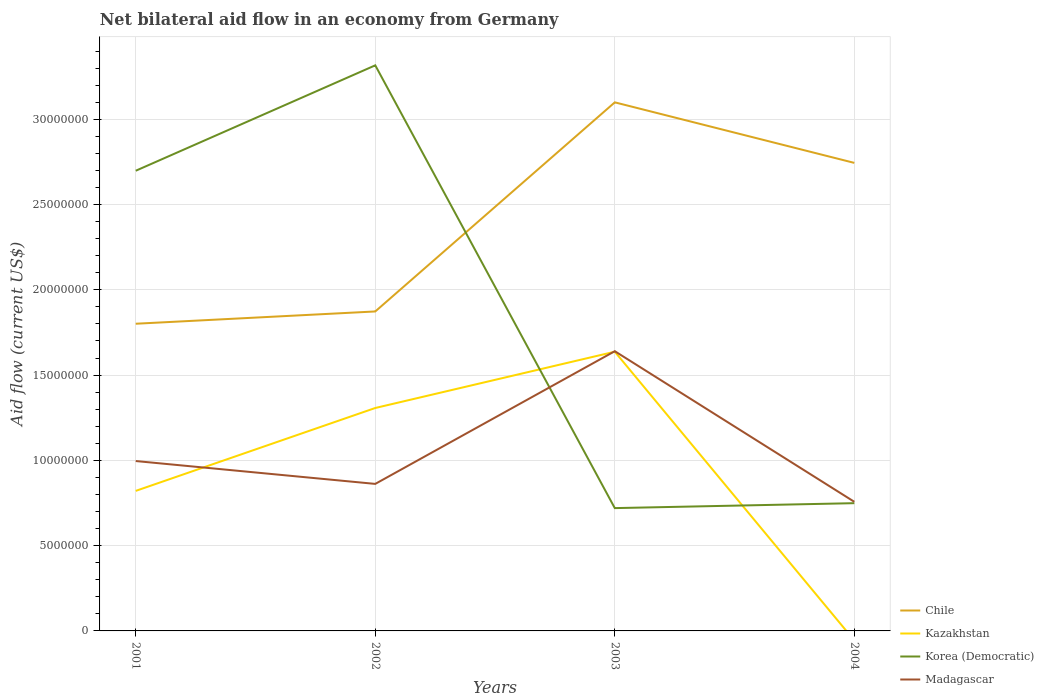How many different coloured lines are there?
Provide a succinct answer. 4. Across all years, what is the maximum net bilateral aid flow in Korea (Democratic)?
Keep it short and to the point. 7.20e+06. What is the total net bilateral aid flow in Madagascar in the graph?
Your answer should be very brief. 2.39e+06. What is the difference between the highest and the second highest net bilateral aid flow in Korea (Democratic)?
Your answer should be compact. 2.60e+07. What is the difference between the highest and the lowest net bilateral aid flow in Kazakhstan?
Provide a succinct answer. 2. Is the net bilateral aid flow in Madagascar strictly greater than the net bilateral aid flow in Kazakhstan over the years?
Ensure brevity in your answer.  No. How many years are there in the graph?
Your answer should be very brief. 4. How many legend labels are there?
Ensure brevity in your answer.  4. What is the title of the graph?
Your answer should be very brief. Net bilateral aid flow in an economy from Germany. What is the label or title of the X-axis?
Offer a terse response. Years. What is the Aid flow (current US$) of Chile in 2001?
Make the answer very short. 1.80e+07. What is the Aid flow (current US$) in Kazakhstan in 2001?
Your response must be concise. 8.21e+06. What is the Aid flow (current US$) in Korea (Democratic) in 2001?
Provide a short and direct response. 2.70e+07. What is the Aid flow (current US$) in Madagascar in 2001?
Ensure brevity in your answer.  9.96e+06. What is the Aid flow (current US$) in Chile in 2002?
Your answer should be very brief. 1.87e+07. What is the Aid flow (current US$) of Kazakhstan in 2002?
Your answer should be very brief. 1.31e+07. What is the Aid flow (current US$) in Korea (Democratic) in 2002?
Your response must be concise. 3.32e+07. What is the Aid flow (current US$) in Madagascar in 2002?
Your answer should be compact. 8.62e+06. What is the Aid flow (current US$) of Chile in 2003?
Provide a short and direct response. 3.10e+07. What is the Aid flow (current US$) in Kazakhstan in 2003?
Offer a very short reply. 1.64e+07. What is the Aid flow (current US$) of Korea (Democratic) in 2003?
Give a very brief answer. 7.20e+06. What is the Aid flow (current US$) of Madagascar in 2003?
Your answer should be very brief. 1.64e+07. What is the Aid flow (current US$) of Chile in 2004?
Give a very brief answer. 2.74e+07. What is the Aid flow (current US$) in Kazakhstan in 2004?
Offer a terse response. 0. What is the Aid flow (current US$) in Korea (Democratic) in 2004?
Ensure brevity in your answer.  7.49e+06. What is the Aid flow (current US$) of Madagascar in 2004?
Offer a very short reply. 7.57e+06. Across all years, what is the maximum Aid flow (current US$) of Chile?
Offer a very short reply. 3.10e+07. Across all years, what is the maximum Aid flow (current US$) of Kazakhstan?
Your answer should be compact. 1.64e+07. Across all years, what is the maximum Aid flow (current US$) in Korea (Democratic)?
Offer a very short reply. 3.32e+07. Across all years, what is the maximum Aid flow (current US$) in Madagascar?
Your answer should be compact. 1.64e+07. Across all years, what is the minimum Aid flow (current US$) in Chile?
Provide a succinct answer. 1.80e+07. Across all years, what is the minimum Aid flow (current US$) of Kazakhstan?
Give a very brief answer. 0. Across all years, what is the minimum Aid flow (current US$) in Korea (Democratic)?
Make the answer very short. 7.20e+06. Across all years, what is the minimum Aid flow (current US$) in Madagascar?
Your answer should be compact. 7.57e+06. What is the total Aid flow (current US$) of Chile in the graph?
Provide a succinct answer. 9.52e+07. What is the total Aid flow (current US$) of Kazakhstan in the graph?
Ensure brevity in your answer.  3.76e+07. What is the total Aid flow (current US$) in Korea (Democratic) in the graph?
Ensure brevity in your answer.  7.48e+07. What is the total Aid flow (current US$) in Madagascar in the graph?
Provide a succinct answer. 4.26e+07. What is the difference between the Aid flow (current US$) in Chile in 2001 and that in 2002?
Offer a very short reply. -7.20e+05. What is the difference between the Aid flow (current US$) of Kazakhstan in 2001 and that in 2002?
Keep it short and to the point. -4.86e+06. What is the difference between the Aid flow (current US$) of Korea (Democratic) in 2001 and that in 2002?
Your response must be concise. -6.18e+06. What is the difference between the Aid flow (current US$) in Madagascar in 2001 and that in 2002?
Your response must be concise. 1.34e+06. What is the difference between the Aid flow (current US$) in Chile in 2001 and that in 2003?
Give a very brief answer. -1.30e+07. What is the difference between the Aid flow (current US$) of Kazakhstan in 2001 and that in 2003?
Provide a short and direct response. -8.16e+06. What is the difference between the Aid flow (current US$) in Korea (Democratic) in 2001 and that in 2003?
Your response must be concise. 1.98e+07. What is the difference between the Aid flow (current US$) in Madagascar in 2001 and that in 2003?
Offer a very short reply. -6.44e+06. What is the difference between the Aid flow (current US$) of Chile in 2001 and that in 2004?
Make the answer very short. -9.43e+06. What is the difference between the Aid flow (current US$) in Korea (Democratic) in 2001 and that in 2004?
Give a very brief answer. 1.95e+07. What is the difference between the Aid flow (current US$) in Madagascar in 2001 and that in 2004?
Keep it short and to the point. 2.39e+06. What is the difference between the Aid flow (current US$) in Chile in 2002 and that in 2003?
Your answer should be very brief. -1.23e+07. What is the difference between the Aid flow (current US$) in Kazakhstan in 2002 and that in 2003?
Offer a terse response. -3.30e+06. What is the difference between the Aid flow (current US$) in Korea (Democratic) in 2002 and that in 2003?
Your answer should be very brief. 2.60e+07. What is the difference between the Aid flow (current US$) of Madagascar in 2002 and that in 2003?
Your answer should be very brief. -7.78e+06. What is the difference between the Aid flow (current US$) in Chile in 2002 and that in 2004?
Your response must be concise. -8.71e+06. What is the difference between the Aid flow (current US$) in Korea (Democratic) in 2002 and that in 2004?
Provide a short and direct response. 2.57e+07. What is the difference between the Aid flow (current US$) of Madagascar in 2002 and that in 2004?
Offer a very short reply. 1.05e+06. What is the difference between the Aid flow (current US$) in Chile in 2003 and that in 2004?
Your answer should be compact. 3.55e+06. What is the difference between the Aid flow (current US$) in Korea (Democratic) in 2003 and that in 2004?
Give a very brief answer. -2.90e+05. What is the difference between the Aid flow (current US$) in Madagascar in 2003 and that in 2004?
Your response must be concise. 8.83e+06. What is the difference between the Aid flow (current US$) of Chile in 2001 and the Aid flow (current US$) of Kazakhstan in 2002?
Your answer should be compact. 4.94e+06. What is the difference between the Aid flow (current US$) of Chile in 2001 and the Aid flow (current US$) of Korea (Democratic) in 2002?
Provide a succinct answer. -1.52e+07. What is the difference between the Aid flow (current US$) in Chile in 2001 and the Aid flow (current US$) in Madagascar in 2002?
Your response must be concise. 9.39e+06. What is the difference between the Aid flow (current US$) in Kazakhstan in 2001 and the Aid flow (current US$) in Korea (Democratic) in 2002?
Give a very brief answer. -2.50e+07. What is the difference between the Aid flow (current US$) in Kazakhstan in 2001 and the Aid flow (current US$) in Madagascar in 2002?
Offer a terse response. -4.10e+05. What is the difference between the Aid flow (current US$) of Korea (Democratic) in 2001 and the Aid flow (current US$) of Madagascar in 2002?
Offer a terse response. 1.84e+07. What is the difference between the Aid flow (current US$) of Chile in 2001 and the Aid flow (current US$) of Kazakhstan in 2003?
Your answer should be very brief. 1.64e+06. What is the difference between the Aid flow (current US$) of Chile in 2001 and the Aid flow (current US$) of Korea (Democratic) in 2003?
Offer a terse response. 1.08e+07. What is the difference between the Aid flow (current US$) of Chile in 2001 and the Aid flow (current US$) of Madagascar in 2003?
Make the answer very short. 1.61e+06. What is the difference between the Aid flow (current US$) of Kazakhstan in 2001 and the Aid flow (current US$) of Korea (Democratic) in 2003?
Keep it short and to the point. 1.01e+06. What is the difference between the Aid flow (current US$) in Kazakhstan in 2001 and the Aid flow (current US$) in Madagascar in 2003?
Make the answer very short. -8.19e+06. What is the difference between the Aid flow (current US$) in Korea (Democratic) in 2001 and the Aid flow (current US$) in Madagascar in 2003?
Ensure brevity in your answer.  1.06e+07. What is the difference between the Aid flow (current US$) of Chile in 2001 and the Aid flow (current US$) of Korea (Democratic) in 2004?
Your response must be concise. 1.05e+07. What is the difference between the Aid flow (current US$) in Chile in 2001 and the Aid flow (current US$) in Madagascar in 2004?
Give a very brief answer. 1.04e+07. What is the difference between the Aid flow (current US$) in Kazakhstan in 2001 and the Aid flow (current US$) in Korea (Democratic) in 2004?
Make the answer very short. 7.20e+05. What is the difference between the Aid flow (current US$) in Kazakhstan in 2001 and the Aid flow (current US$) in Madagascar in 2004?
Your response must be concise. 6.40e+05. What is the difference between the Aid flow (current US$) of Korea (Democratic) in 2001 and the Aid flow (current US$) of Madagascar in 2004?
Keep it short and to the point. 1.94e+07. What is the difference between the Aid flow (current US$) of Chile in 2002 and the Aid flow (current US$) of Kazakhstan in 2003?
Ensure brevity in your answer.  2.36e+06. What is the difference between the Aid flow (current US$) in Chile in 2002 and the Aid flow (current US$) in Korea (Democratic) in 2003?
Make the answer very short. 1.15e+07. What is the difference between the Aid flow (current US$) of Chile in 2002 and the Aid flow (current US$) of Madagascar in 2003?
Give a very brief answer. 2.33e+06. What is the difference between the Aid flow (current US$) of Kazakhstan in 2002 and the Aid flow (current US$) of Korea (Democratic) in 2003?
Give a very brief answer. 5.87e+06. What is the difference between the Aid flow (current US$) of Kazakhstan in 2002 and the Aid flow (current US$) of Madagascar in 2003?
Your answer should be compact. -3.33e+06. What is the difference between the Aid flow (current US$) of Korea (Democratic) in 2002 and the Aid flow (current US$) of Madagascar in 2003?
Ensure brevity in your answer.  1.68e+07. What is the difference between the Aid flow (current US$) of Chile in 2002 and the Aid flow (current US$) of Korea (Democratic) in 2004?
Your response must be concise. 1.12e+07. What is the difference between the Aid flow (current US$) in Chile in 2002 and the Aid flow (current US$) in Madagascar in 2004?
Give a very brief answer. 1.12e+07. What is the difference between the Aid flow (current US$) in Kazakhstan in 2002 and the Aid flow (current US$) in Korea (Democratic) in 2004?
Your answer should be compact. 5.58e+06. What is the difference between the Aid flow (current US$) in Kazakhstan in 2002 and the Aid flow (current US$) in Madagascar in 2004?
Offer a terse response. 5.50e+06. What is the difference between the Aid flow (current US$) in Korea (Democratic) in 2002 and the Aid flow (current US$) in Madagascar in 2004?
Ensure brevity in your answer.  2.56e+07. What is the difference between the Aid flow (current US$) in Chile in 2003 and the Aid flow (current US$) in Korea (Democratic) in 2004?
Provide a succinct answer. 2.35e+07. What is the difference between the Aid flow (current US$) in Chile in 2003 and the Aid flow (current US$) in Madagascar in 2004?
Offer a terse response. 2.34e+07. What is the difference between the Aid flow (current US$) of Kazakhstan in 2003 and the Aid flow (current US$) of Korea (Democratic) in 2004?
Provide a short and direct response. 8.88e+06. What is the difference between the Aid flow (current US$) in Kazakhstan in 2003 and the Aid flow (current US$) in Madagascar in 2004?
Your answer should be very brief. 8.80e+06. What is the difference between the Aid flow (current US$) in Korea (Democratic) in 2003 and the Aid flow (current US$) in Madagascar in 2004?
Your response must be concise. -3.70e+05. What is the average Aid flow (current US$) of Chile per year?
Ensure brevity in your answer.  2.38e+07. What is the average Aid flow (current US$) of Kazakhstan per year?
Provide a succinct answer. 9.41e+06. What is the average Aid flow (current US$) in Korea (Democratic) per year?
Offer a very short reply. 1.87e+07. What is the average Aid flow (current US$) of Madagascar per year?
Provide a succinct answer. 1.06e+07. In the year 2001, what is the difference between the Aid flow (current US$) of Chile and Aid flow (current US$) of Kazakhstan?
Offer a terse response. 9.80e+06. In the year 2001, what is the difference between the Aid flow (current US$) of Chile and Aid flow (current US$) of Korea (Democratic)?
Give a very brief answer. -8.97e+06. In the year 2001, what is the difference between the Aid flow (current US$) of Chile and Aid flow (current US$) of Madagascar?
Offer a very short reply. 8.05e+06. In the year 2001, what is the difference between the Aid flow (current US$) of Kazakhstan and Aid flow (current US$) of Korea (Democratic)?
Offer a very short reply. -1.88e+07. In the year 2001, what is the difference between the Aid flow (current US$) in Kazakhstan and Aid flow (current US$) in Madagascar?
Ensure brevity in your answer.  -1.75e+06. In the year 2001, what is the difference between the Aid flow (current US$) of Korea (Democratic) and Aid flow (current US$) of Madagascar?
Make the answer very short. 1.70e+07. In the year 2002, what is the difference between the Aid flow (current US$) of Chile and Aid flow (current US$) of Kazakhstan?
Offer a very short reply. 5.66e+06. In the year 2002, what is the difference between the Aid flow (current US$) in Chile and Aid flow (current US$) in Korea (Democratic)?
Offer a terse response. -1.44e+07. In the year 2002, what is the difference between the Aid flow (current US$) of Chile and Aid flow (current US$) of Madagascar?
Make the answer very short. 1.01e+07. In the year 2002, what is the difference between the Aid flow (current US$) in Kazakhstan and Aid flow (current US$) in Korea (Democratic)?
Your answer should be very brief. -2.01e+07. In the year 2002, what is the difference between the Aid flow (current US$) in Kazakhstan and Aid flow (current US$) in Madagascar?
Your answer should be compact. 4.45e+06. In the year 2002, what is the difference between the Aid flow (current US$) in Korea (Democratic) and Aid flow (current US$) in Madagascar?
Your answer should be very brief. 2.45e+07. In the year 2003, what is the difference between the Aid flow (current US$) in Chile and Aid flow (current US$) in Kazakhstan?
Offer a terse response. 1.46e+07. In the year 2003, what is the difference between the Aid flow (current US$) in Chile and Aid flow (current US$) in Korea (Democratic)?
Make the answer very short. 2.38e+07. In the year 2003, what is the difference between the Aid flow (current US$) of Chile and Aid flow (current US$) of Madagascar?
Give a very brief answer. 1.46e+07. In the year 2003, what is the difference between the Aid flow (current US$) in Kazakhstan and Aid flow (current US$) in Korea (Democratic)?
Provide a short and direct response. 9.17e+06. In the year 2003, what is the difference between the Aid flow (current US$) of Korea (Democratic) and Aid flow (current US$) of Madagascar?
Your answer should be very brief. -9.20e+06. In the year 2004, what is the difference between the Aid flow (current US$) of Chile and Aid flow (current US$) of Korea (Democratic)?
Provide a succinct answer. 2.00e+07. In the year 2004, what is the difference between the Aid flow (current US$) in Chile and Aid flow (current US$) in Madagascar?
Keep it short and to the point. 1.99e+07. In the year 2004, what is the difference between the Aid flow (current US$) of Korea (Democratic) and Aid flow (current US$) of Madagascar?
Make the answer very short. -8.00e+04. What is the ratio of the Aid flow (current US$) of Chile in 2001 to that in 2002?
Ensure brevity in your answer.  0.96. What is the ratio of the Aid flow (current US$) of Kazakhstan in 2001 to that in 2002?
Offer a terse response. 0.63. What is the ratio of the Aid flow (current US$) in Korea (Democratic) in 2001 to that in 2002?
Give a very brief answer. 0.81. What is the ratio of the Aid flow (current US$) in Madagascar in 2001 to that in 2002?
Keep it short and to the point. 1.16. What is the ratio of the Aid flow (current US$) in Chile in 2001 to that in 2003?
Ensure brevity in your answer.  0.58. What is the ratio of the Aid flow (current US$) in Kazakhstan in 2001 to that in 2003?
Your answer should be very brief. 0.5. What is the ratio of the Aid flow (current US$) of Korea (Democratic) in 2001 to that in 2003?
Offer a terse response. 3.75. What is the ratio of the Aid flow (current US$) in Madagascar in 2001 to that in 2003?
Provide a short and direct response. 0.61. What is the ratio of the Aid flow (current US$) of Chile in 2001 to that in 2004?
Your response must be concise. 0.66. What is the ratio of the Aid flow (current US$) in Korea (Democratic) in 2001 to that in 2004?
Provide a short and direct response. 3.6. What is the ratio of the Aid flow (current US$) of Madagascar in 2001 to that in 2004?
Give a very brief answer. 1.32. What is the ratio of the Aid flow (current US$) in Chile in 2002 to that in 2003?
Your answer should be compact. 0.6. What is the ratio of the Aid flow (current US$) in Kazakhstan in 2002 to that in 2003?
Ensure brevity in your answer.  0.8. What is the ratio of the Aid flow (current US$) in Korea (Democratic) in 2002 to that in 2003?
Your response must be concise. 4.61. What is the ratio of the Aid flow (current US$) of Madagascar in 2002 to that in 2003?
Provide a succinct answer. 0.53. What is the ratio of the Aid flow (current US$) in Chile in 2002 to that in 2004?
Your answer should be compact. 0.68. What is the ratio of the Aid flow (current US$) of Korea (Democratic) in 2002 to that in 2004?
Offer a terse response. 4.43. What is the ratio of the Aid flow (current US$) of Madagascar in 2002 to that in 2004?
Provide a succinct answer. 1.14. What is the ratio of the Aid flow (current US$) of Chile in 2003 to that in 2004?
Your answer should be very brief. 1.13. What is the ratio of the Aid flow (current US$) in Korea (Democratic) in 2003 to that in 2004?
Ensure brevity in your answer.  0.96. What is the ratio of the Aid flow (current US$) of Madagascar in 2003 to that in 2004?
Offer a terse response. 2.17. What is the difference between the highest and the second highest Aid flow (current US$) of Chile?
Offer a very short reply. 3.55e+06. What is the difference between the highest and the second highest Aid flow (current US$) of Kazakhstan?
Your answer should be compact. 3.30e+06. What is the difference between the highest and the second highest Aid flow (current US$) of Korea (Democratic)?
Offer a very short reply. 6.18e+06. What is the difference between the highest and the second highest Aid flow (current US$) of Madagascar?
Your answer should be compact. 6.44e+06. What is the difference between the highest and the lowest Aid flow (current US$) of Chile?
Ensure brevity in your answer.  1.30e+07. What is the difference between the highest and the lowest Aid flow (current US$) in Kazakhstan?
Make the answer very short. 1.64e+07. What is the difference between the highest and the lowest Aid flow (current US$) of Korea (Democratic)?
Offer a very short reply. 2.60e+07. What is the difference between the highest and the lowest Aid flow (current US$) of Madagascar?
Your answer should be very brief. 8.83e+06. 